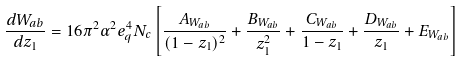Convert formula to latex. <formula><loc_0><loc_0><loc_500><loc_500>\frac { d W _ { a b } } { d z _ { 1 } } = 1 6 \pi ^ { 2 } \alpha ^ { 2 } e _ { q } ^ { 4 } N _ { c } \left [ \frac { A _ { W _ { a b } } } { ( 1 - z _ { 1 } ) ^ { 2 } } + \frac { B _ { W _ { a b } } } { z _ { 1 } ^ { 2 } } + \frac { C _ { W _ { a b } } } { 1 - z _ { 1 } } + \frac { D _ { W _ { a b } } } { z _ { 1 } } + E _ { W _ { a b } } \right ]</formula> 